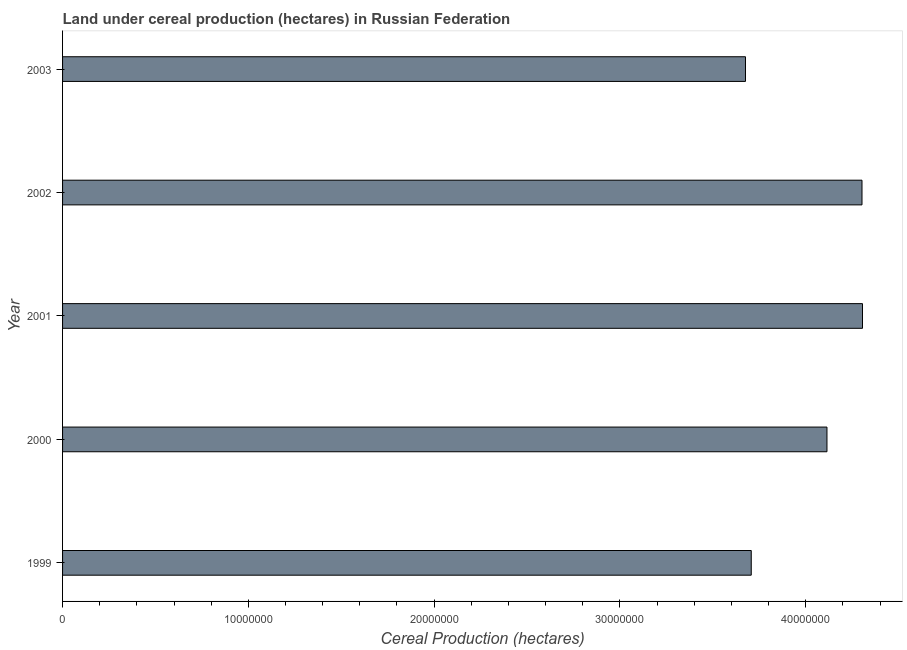Does the graph contain any zero values?
Make the answer very short. No. What is the title of the graph?
Offer a very short reply. Land under cereal production (hectares) in Russian Federation. What is the label or title of the X-axis?
Your answer should be very brief. Cereal Production (hectares). What is the label or title of the Y-axis?
Make the answer very short. Year. What is the land under cereal production in 2000?
Your answer should be very brief. 4.11e+07. Across all years, what is the maximum land under cereal production?
Your response must be concise. 4.31e+07. Across all years, what is the minimum land under cereal production?
Your answer should be compact. 3.68e+07. In which year was the land under cereal production minimum?
Offer a very short reply. 2003. What is the sum of the land under cereal production?
Keep it short and to the point. 2.01e+08. What is the difference between the land under cereal production in 1999 and 2000?
Your answer should be compact. -4.08e+06. What is the average land under cereal production per year?
Your response must be concise. 4.02e+07. What is the median land under cereal production?
Your response must be concise. 4.11e+07. What is the ratio of the land under cereal production in 2000 to that in 2003?
Keep it short and to the point. 1.12. Is the land under cereal production in 1999 less than that in 2002?
Provide a succinct answer. Yes. What is the difference between the highest and the second highest land under cereal production?
Provide a short and direct response. 2.69e+04. What is the difference between the highest and the lowest land under cereal production?
Keep it short and to the point. 6.30e+06. How many bars are there?
Provide a short and direct response. 5. How many years are there in the graph?
Give a very brief answer. 5. Are the values on the major ticks of X-axis written in scientific E-notation?
Keep it short and to the point. No. What is the Cereal Production (hectares) of 1999?
Your answer should be compact. 3.71e+07. What is the Cereal Production (hectares) of 2000?
Your response must be concise. 4.11e+07. What is the Cereal Production (hectares) in 2001?
Make the answer very short. 4.31e+07. What is the Cereal Production (hectares) in 2002?
Your response must be concise. 4.30e+07. What is the Cereal Production (hectares) in 2003?
Give a very brief answer. 3.68e+07. What is the difference between the Cereal Production (hectares) in 1999 and 2000?
Make the answer very short. -4.08e+06. What is the difference between the Cereal Production (hectares) in 1999 and 2001?
Your answer should be very brief. -5.99e+06. What is the difference between the Cereal Production (hectares) in 1999 and 2002?
Offer a terse response. -5.96e+06. What is the difference between the Cereal Production (hectares) in 1999 and 2003?
Offer a terse response. 3.10e+05. What is the difference between the Cereal Production (hectares) in 2000 and 2001?
Offer a very short reply. -1.91e+06. What is the difference between the Cereal Production (hectares) in 2000 and 2002?
Your response must be concise. -1.89e+06. What is the difference between the Cereal Production (hectares) in 2000 and 2003?
Offer a terse response. 4.39e+06. What is the difference between the Cereal Production (hectares) in 2001 and 2002?
Make the answer very short. 2.69e+04. What is the difference between the Cereal Production (hectares) in 2001 and 2003?
Your answer should be very brief. 6.30e+06. What is the difference between the Cereal Production (hectares) in 2002 and 2003?
Offer a terse response. 6.27e+06. What is the ratio of the Cereal Production (hectares) in 1999 to that in 2000?
Make the answer very short. 0.9. What is the ratio of the Cereal Production (hectares) in 1999 to that in 2001?
Give a very brief answer. 0.86. What is the ratio of the Cereal Production (hectares) in 1999 to that in 2002?
Give a very brief answer. 0.86. What is the ratio of the Cereal Production (hectares) in 1999 to that in 2003?
Keep it short and to the point. 1.01. What is the ratio of the Cereal Production (hectares) in 2000 to that in 2001?
Ensure brevity in your answer.  0.96. What is the ratio of the Cereal Production (hectares) in 2000 to that in 2002?
Your response must be concise. 0.96. What is the ratio of the Cereal Production (hectares) in 2000 to that in 2003?
Your response must be concise. 1.12. What is the ratio of the Cereal Production (hectares) in 2001 to that in 2002?
Your answer should be very brief. 1. What is the ratio of the Cereal Production (hectares) in 2001 to that in 2003?
Provide a succinct answer. 1.17. What is the ratio of the Cereal Production (hectares) in 2002 to that in 2003?
Your answer should be compact. 1.17. 